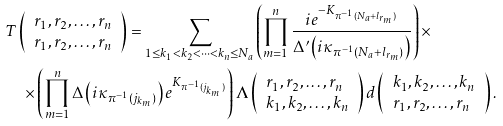<formula> <loc_0><loc_0><loc_500><loc_500>& T \left ( \begin{array} { l } r _ { 1 } , r _ { 2 } , \dots , r _ { n } \\ r _ { 1 } , r _ { 2 } , \dots , r _ { n } \end{array} \right ) = \sum _ { 1 \leq k _ { 1 } < k _ { 2 } < \dots < k _ { n } \leq N _ { a } } \left ( \prod _ { m = 1 } ^ { n } \frac { i e ^ { - K _ { \pi ^ { - 1 } ( N _ { a } + l _ { r _ { m } } ) } } } { \Delta ^ { \prime } \left ( i \kappa _ { \pi ^ { - 1 } ( N _ { a } + l _ { r _ { m } } ) } \right ) } \right ) \times \\ & \quad \times \left ( \prod _ { m = 1 } ^ { n } \Delta \left ( i \kappa _ { \pi ^ { - 1 } ( j _ { k _ { m } } ) } \right ) e ^ { K _ { \pi ^ { - 1 } ( j _ { k _ { m } } ) } } \right ) \Lambda \left ( \begin{array} { l } r _ { 1 } , r _ { 2 } , \dots , r _ { n } \\ k _ { 1 } , k _ { 2 } , \dots , k _ { n } \end{array} \right ) d \left ( \begin{array} { l } k _ { 1 } , k _ { 2 } , \dots , k _ { n } \\ r _ { 1 } , r _ { 2 } , \dots , r _ { n } \end{array} \right ) .</formula> 